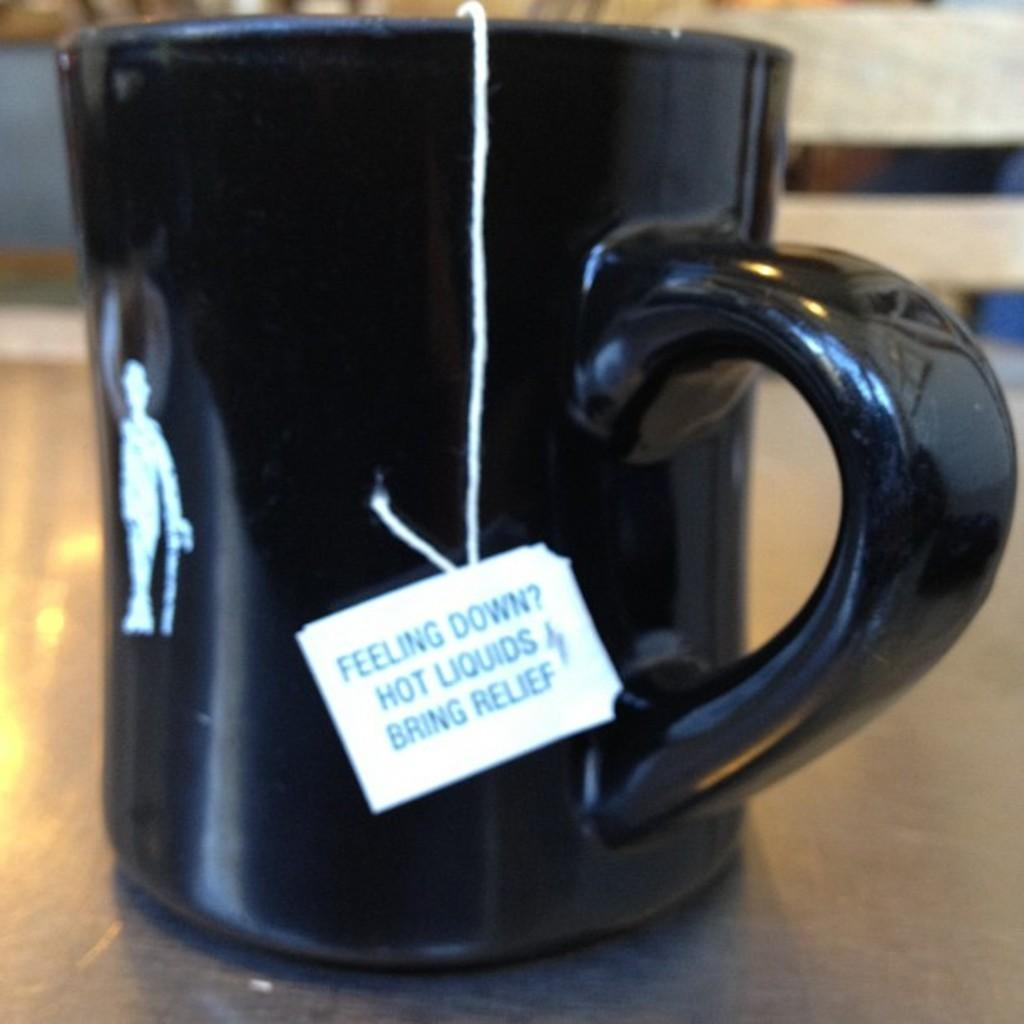<image>
Describe the image concisely. A black mug on a table with a teabag that says Feeling Down Hot Liquids Bring Relief 